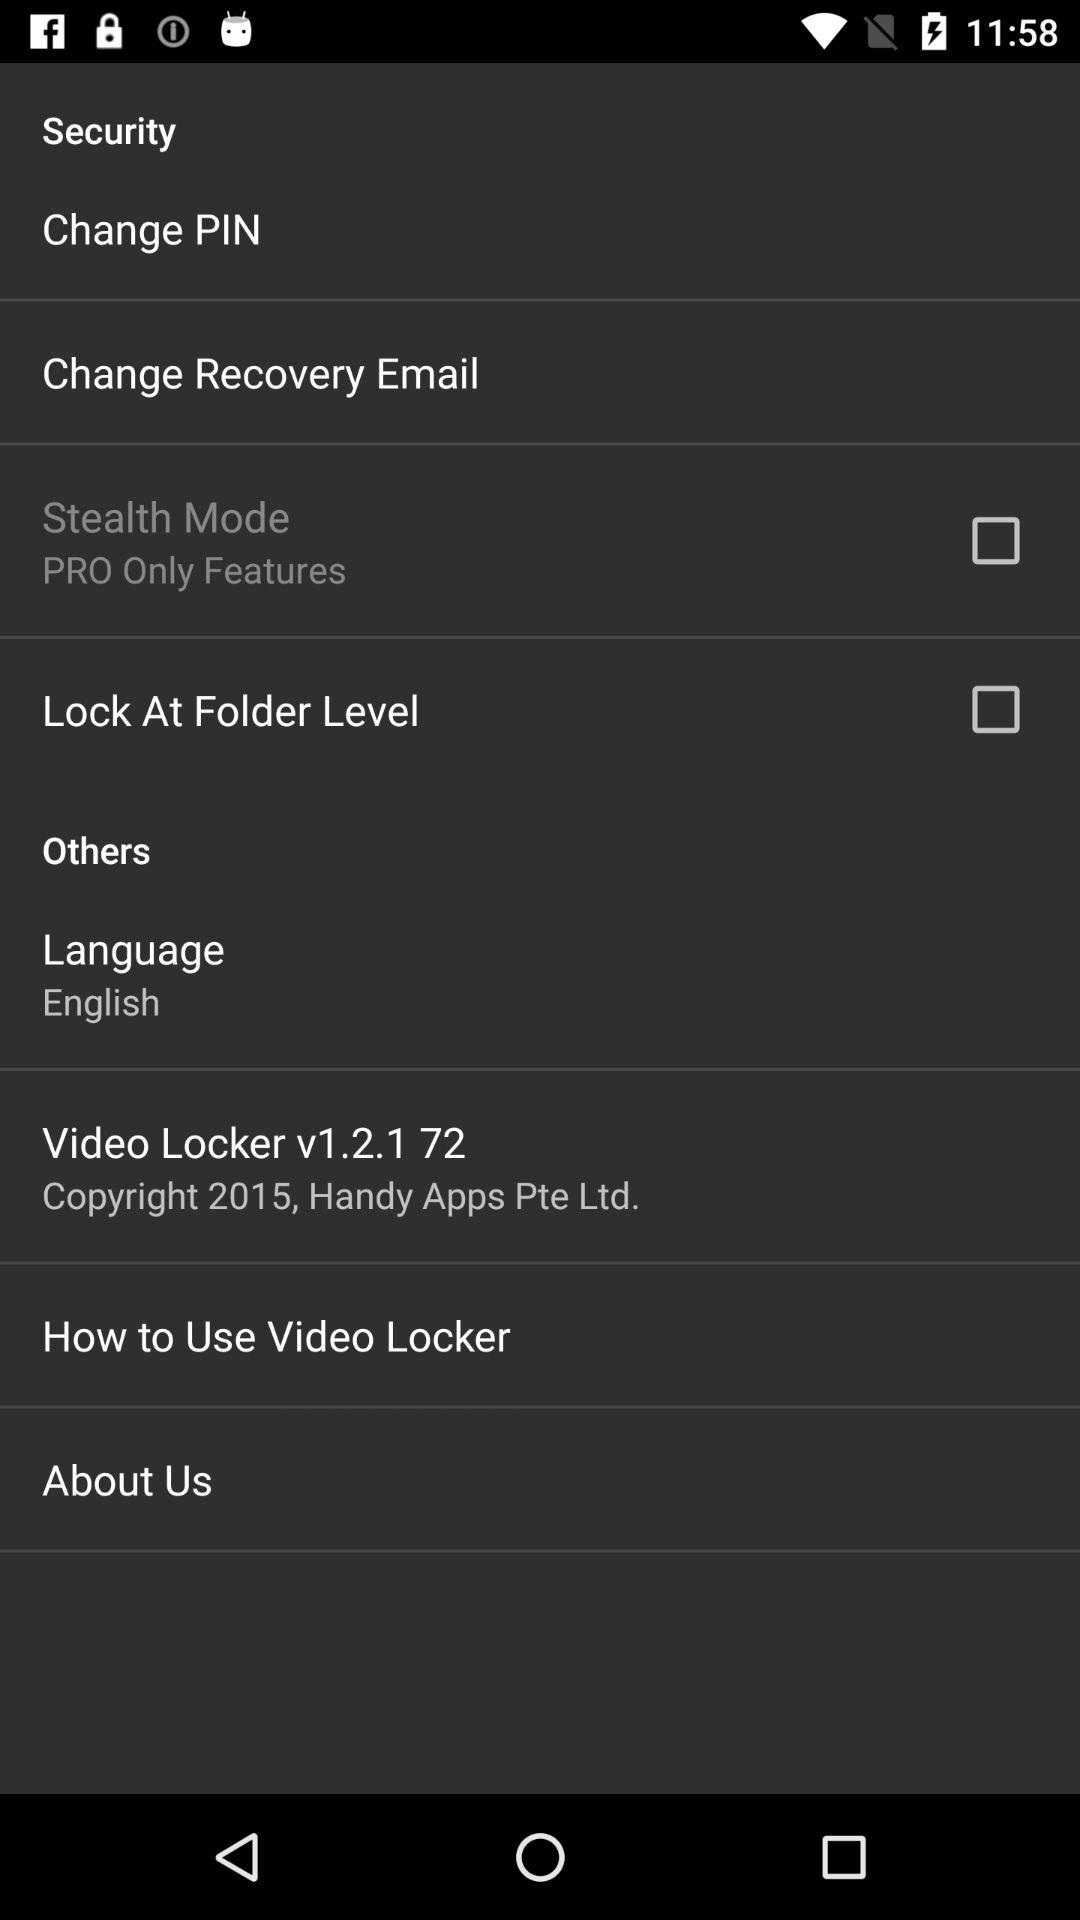What is the selected language? The selected language is English. 